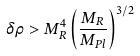Convert formula to latex. <formula><loc_0><loc_0><loc_500><loc_500>\delta \rho > M _ { R } ^ { 4 } \left ( \frac { M _ { R } } { M _ { P l } } \right ) ^ { 3 / 2 }</formula> 